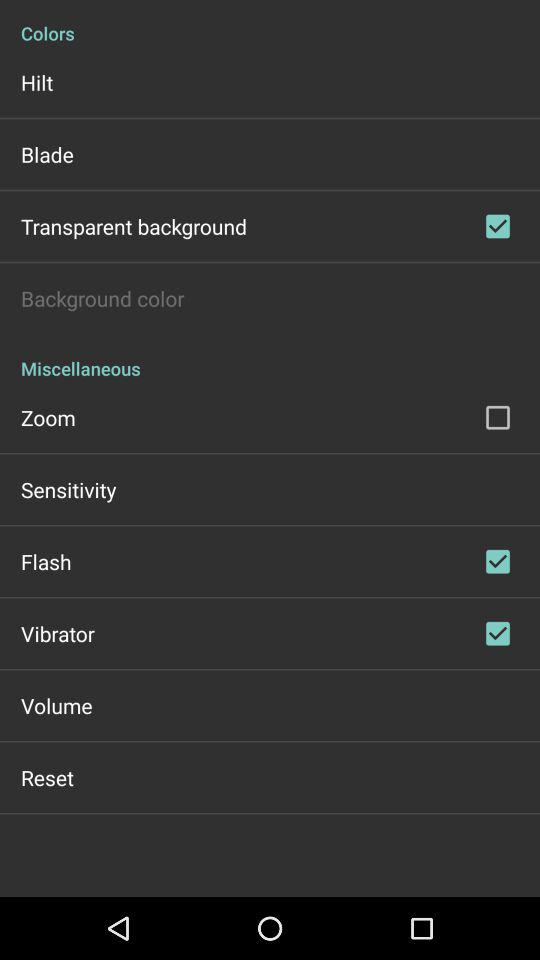What is the current status of the flash? The status is on. 